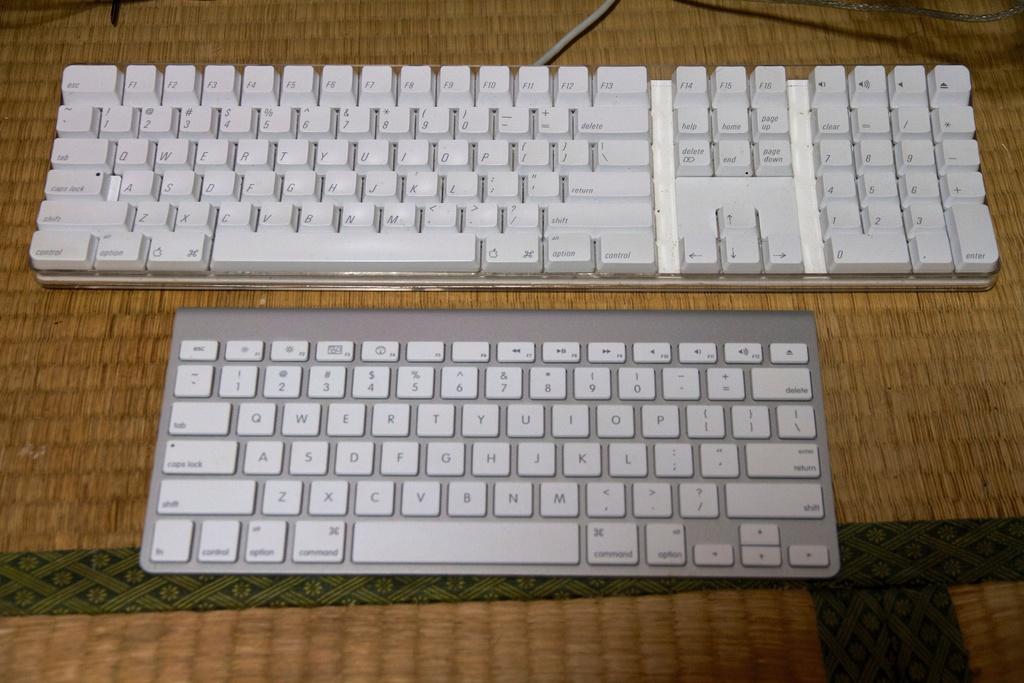What is the first number on the keyboard?
Offer a very short reply. 1. 